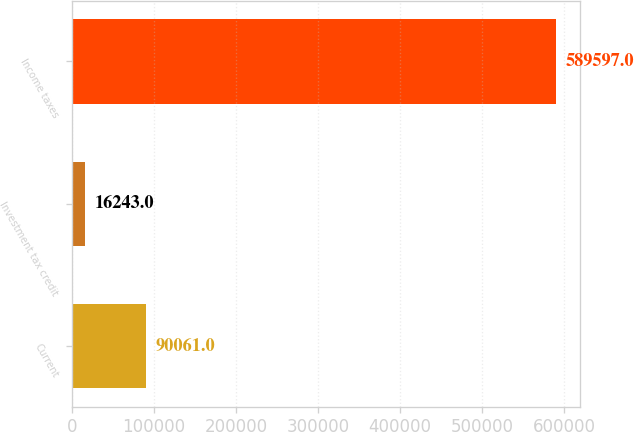Convert chart to OTSL. <chart><loc_0><loc_0><loc_500><loc_500><bar_chart><fcel>Current<fcel>Investment tax credit<fcel>Income taxes<nl><fcel>90061<fcel>16243<fcel>589597<nl></chart> 